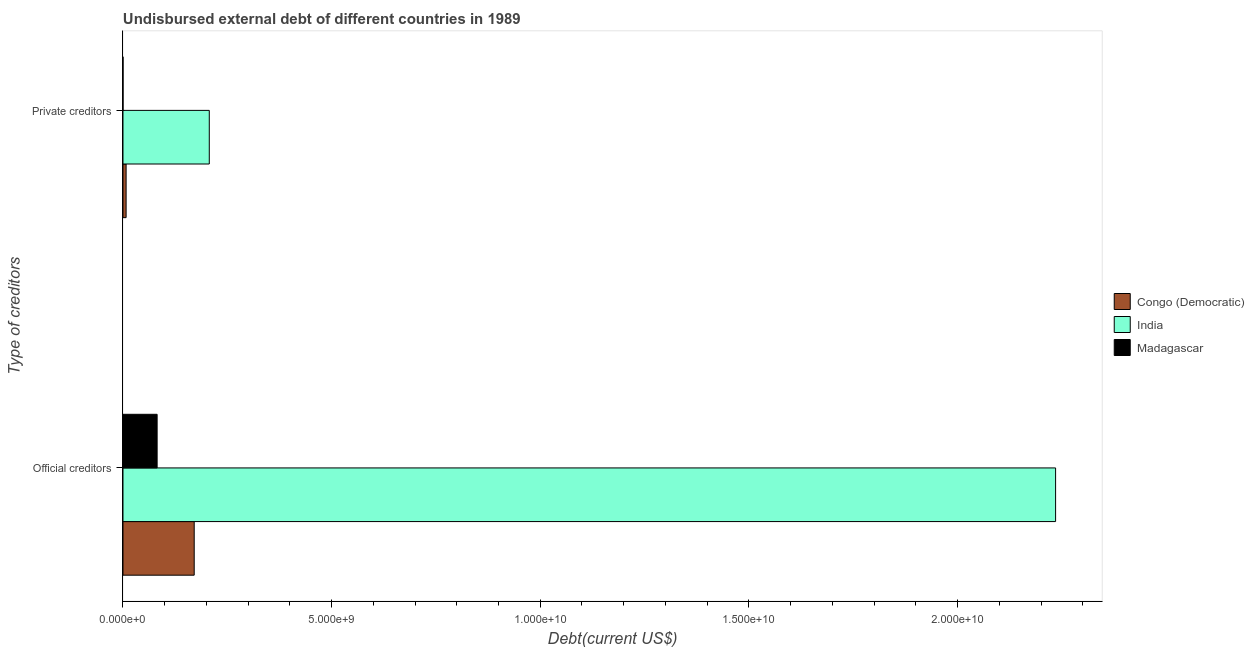How many groups of bars are there?
Ensure brevity in your answer.  2. Are the number of bars on each tick of the Y-axis equal?
Keep it short and to the point. Yes. What is the label of the 2nd group of bars from the top?
Provide a short and direct response. Official creditors. What is the undisbursed external debt of private creditors in Madagascar?
Offer a terse response. 3.77e+05. Across all countries, what is the maximum undisbursed external debt of official creditors?
Your answer should be compact. 2.23e+1. Across all countries, what is the minimum undisbursed external debt of private creditors?
Make the answer very short. 3.77e+05. In which country was the undisbursed external debt of official creditors minimum?
Provide a short and direct response. Madagascar. What is the total undisbursed external debt of official creditors in the graph?
Make the answer very short. 2.49e+1. What is the difference between the undisbursed external debt of official creditors in Congo (Democratic) and that in India?
Your answer should be very brief. -2.06e+1. What is the difference between the undisbursed external debt of official creditors in Congo (Democratic) and the undisbursed external debt of private creditors in Madagascar?
Offer a very short reply. 1.71e+09. What is the average undisbursed external debt of private creditors per country?
Your response must be concise. 7.15e+08. What is the difference between the undisbursed external debt of private creditors and undisbursed external debt of official creditors in Congo (Democratic)?
Ensure brevity in your answer.  -1.63e+09. In how many countries, is the undisbursed external debt of official creditors greater than 19000000000 US$?
Keep it short and to the point. 1. What is the ratio of the undisbursed external debt of private creditors in Madagascar to that in Congo (Democratic)?
Your answer should be very brief. 0.01. In how many countries, is the undisbursed external debt of private creditors greater than the average undisbursed external debt of private creditors taken over all countries?
Give a very brief answer. 1. What does the 3rd bar from the bottom in Official creditors represents?
Provide a short and direct response. Madagascar. How many bars are there?
Make the answer very short. 6. Are the values on the major ticks of X-axis written in scientific E-notation?
Keep it short and to the point. Yes. Where does the legend appear in the graph?
Provide a succinct answer. Center right. What is the title of the graph?
Provide a short and direct response. Undisbursed external debt of different countries in 1989. What is the label or title of the X-axis?
Your answer should be compact. Debt(current US$). What is the label or title of the Y-axis?
Offer a very short reply. Type of creditors. What is the Debt(current US$) of Congo (Democratic) in Official creditors?
Your answer should be very brief. 1.71e+09. What is the Debt(current US$) in India in Official creditors?
Provide a succinct answer. 2.23e+1. What is the Debt(current US$) of Madagascar in Official creditors?
Provide a succinct answer. 8.18e+08. What is the Debt(current US$) of Congo (Democratic) in Private creditors?
Ensure brevity in your answer.  7.50e+07. What is the Debt(current US$) of India in Private creditors?
Keep it short and to the point. 2.07e+09. What is the Debt(current US$) of Madagascar in Private creditors?
Offer a terse response. 3.77e+05. Across all Type of creditors, what is the maximum Debt(current US$) in Congo (Democratic)?
Your response must be concise. 1.71e+09. Across all Type of creditors, what is the maximum Debt(current US$) of India?
Offer a very short reply. 2.23e+1. Across all Type of creditors, what is the maximum Debt(current US$) of Madagascar?
Your response must be concise. 8.18e+08. Across all Type of creditors, what is the minimum Debt(current US$) in Congo (Democratic)?
Keep it short and to the point. 7.50e+07. Across all Type of creditors, what is the minimum Debt(current US$) in India?
Keep it short and to the point. 2.07e+09. Across all Type of creditors, what is the minimum Debt(current US$) in Madagascar?
Give a very brief answer. 3.77e+05. What is the total Debt(current US$) of Congo (Democratic) in the graph?
Your response must be concise. 1.78e+09. What is the total Debt(current US$) of India in the graph?
Keep it short and to the point. 2.44e+1. What is the total Debt(current US$) of Madagascar in the graph?
Ensure brevity in your answer.  8.19e+08. What is the difference between the Debt(current US$) of Congo (Democratic) in Official creditors and that in Private creditors?
Give a very brief answer. 1.63e+09. What is the difference between the Debt(current US$) in India in Official creditors and that in Private creditors?
Your answer should be compact. 2.03e+1. What is the difference between the Debt(current US$) in Madagascar in Official creditors and that in Private creditors?
Provide a short and direct response. 8.18e+08. What is the difference between the Debt(current US$) of Congo (Democratic) in Official creditors and the Debt(current US$) of India in Private creditors?
Your answer should be compact. -3.61e+08. What is the difference between the Debt(current US$) of Congo (Democratic) in Official creditors and the Debt(current US$) of Madagascar in Private creditors?
Ensure brevity in your answer.  1.71e+09. What is the difference between the Debt(current US$) of India in Official creditors and the Debt(current US$) of Madagascar in Private creditors?
Offer a very short reply. 2.23e+1. What is the average Debt(current US$) of Congo (Democratic) per Type of creditors?
Provide a short and direct response. 8.91e+08. What is the average Debt(current US$) of India per Type of creditors?
Your answer should be compact. 1.22e+1. What is the average Debt(current US$) in Madagascar per Type of creditors?
Offer a very short reply. 4.09e+08. What is the difference between the Debt(current US$) in Congo (Democratic) and Debt(current US$) in India in Official creditors?
Your response must be concise. -2.06e+1. What is the difference between the Debt(current US$) of Congo (Democratic) and Debt(current US$) of Madagascar in Official creditors?
Offer a terse response. 8.89e+08. What is the difference between the Debt(current US$) of India and Debt(current US$) of Madagascar in Official creditors?
Ensure brevity in your answer.  2.15e+1. What is the difference between the Debt(current US$) of Congo (Democratic) and Debt(current US$) of India in Private creditors?
Keep it short and to the point. -1.99e+09. What is the difference between the Debt(current US$) in Congo (Democratic) and Debt(current US$) in Madagascar in Private creditors?
Offer a terse response. 7.46e+07. What is the difference between the Debt(current US$) in India and Debt(current US$) in Madagascar in Private creditors?
Offer a very short reply. 2.07e+09. What is the ratio of the Debt(current US$) in Congo (Democratic) in Official creditors to that in Private creditors?
Offer a terse response. 22.77. What is the ratio of the Debt(current US$) of India in Official creditors to that in Private creditors?
Your answer should be compact. 10.81. What is the ratio of the Debt(current US$) in Madagascar in Official creditors to that in Private creditors?
Your response must be concise. 2170.63. What is the difference between the highest and the second highest Debt(current US$) in Congo (Democratic)?
Your answer should be compact. 1.63e+09. What is the difference between the highest and the second highest Debt(current US$) in India?
Ensure brevity in your answer.  2.03e+1. What is the difference between the highest and the second highest Debt(current US$) in Madagascar?
Your answer should be very brief. 8.18e+08. What is the difference between the highest and the lowest Debt(current US$) of Congo (Democratic)?
Ensure brevity in your answer.  1.63e+09. What is the difference between the highest and the lowest Debt(current US$) of India?
Give a very brief answer. 2.03e+1. What is the difference between the highest and the lowest Debt(current US$) in Madagascar?
Give a very brief answer. 8.18e+08. 